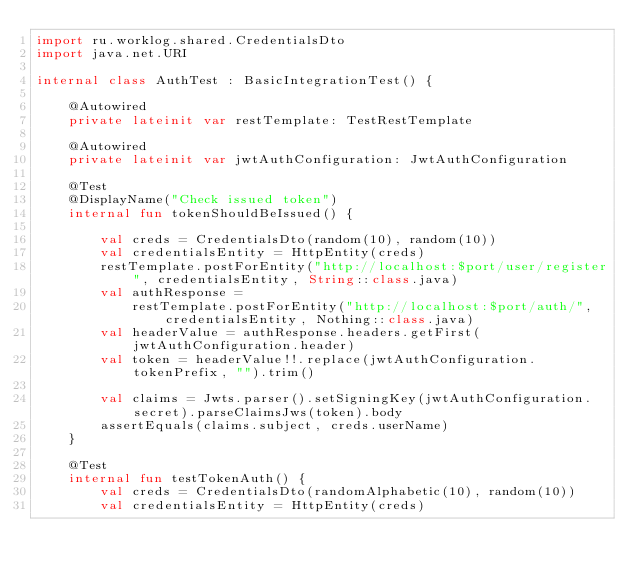Convert code to text. <code><loc_0><loc_0><loc_500><loc_500><_Kotlin_>import ru.worklog.shared.CredentialsDto
import java.net.URI

internal class AuthTest : BasicIntegrationTest() {

    @Autowired
    private lateinit var restTemplate: TestRestTemplate

    @Autowired
    private lateinit var jwtAuthConfiguration: JwtAuthConfiguration

    @Test
    @DisplayName("Check issued token")
    internal fun tokenShouldBeIssued() {

        val creds = CredentialsDto(random(10), random(10))
        val credentialsEntity = HttpEntity(creds)
        restTemplate.postForEntity("http://localhost:$port/user/register", credentialsEntity, String::class.java)
        val authResponse =
            restTemplate.postForEntity("http://localhost:$port/auth/", credentialsEntity, Nothing::class.java)
        val headerValue = authResponse.headers.getFirst(jwtAuthConfiguration.header)
        val token = headerValue!!.replace(jwtAuthConfiguration.tokenPrefix, "").trim()

        val claims = Jwts.parser().setSigningKey(jwtAuthConfiguration.secret).parseClaimsJws(token).body
        assertEquals(claims.subject, creds.userName)
    }

    @Test
    internal fun testTokenAuth() {
        val creds = CredentialsDto(randomAlphabetic(10), random(10))
        val credentialsEntity = HttpEntity(creds)</code> 